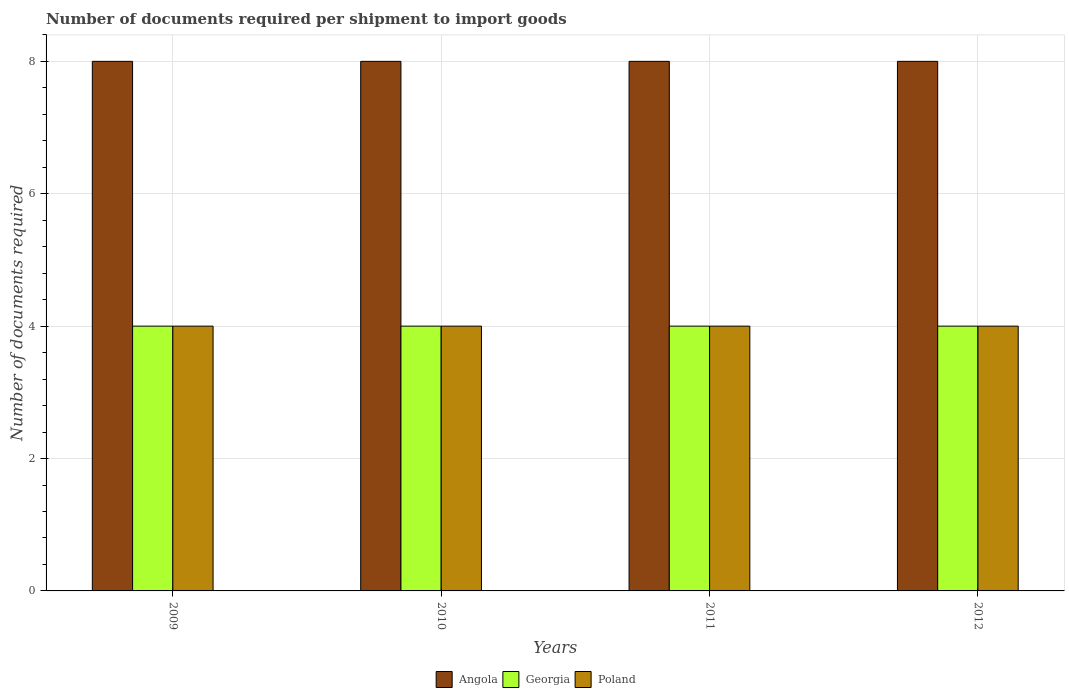Are the number of bars on each tick of the X-axis equal?
Offer a terse response. Yes. What is the label of the 1st group of bars from the left?
Provide a succinct answer. 2009. In how many cases, is the number of bars for a given year not equal to the number of legend labels?
Provide a short and direct response. 0. What is the number of documents required per shipment to import goods in Poland in 2012?
Offer a very short reply. 4. Across all years, what is the maximum number of documents required per shipment to import goods in Angola?
Provide a short and direct response. 8. Across all years, what is the minimum number of documents required per shipment to import goods in Angola?
Offer a very short reply. 8. In which year was the number of documents required per shipment to import goods in Georgia maximum?
Provide a short and direct response. 2009. In which year was the number of documents required per shipment to import goods in Poland minimum?
Provide a succinct answer. 2009. What is the total number of documents required per shipment to import goods in Georgia in the graph?
Ensure brevity in your answer.  16. What is the difference between the number of documents required per shipment to import goods in Angola in 2011 and the number of documents required per shipment to import goods in Poland in 2009?
Offer a very short reply. 4. In the year 2009, what is the difference between the number of documents required per shipment to import goods in Poland and number of documents required per shipment to import goods in Angola?
Your answer should be very brief. -4. In how many years, is the number of documents required per shipment to import goods in Angola greater than 2.4?
Your answer should be compact. 4. Is the number of documents required per shipment to import goods in Georgia in 2010 less than that in 2011?
Give a very brief answer. No. What is the difference between the highest and the second highest number of documents required per shipment to import goods in Poland?
Your answer should be very brief. 0. Is the sum of the number of documents required per shipment to import goods in Angola in 2010 and 2012 greater than the maximum number of documents required per shipment to import goods in Georgia across all years?
Provide a short and direct response. Yes. What does the 1st bar from the left in 2009 represents?
Make the answer very short. Angola. What does the 3rd bar from the right in 2011 represents?
Provide a short and direct response. Angola. Is it the case that in every year, the sum of the number of documents required per shipment to import goods in Georgia and number of documents required per shipment to import goods in Angola is greater than the number of documents required per shipment to import goods in Poland?
Provide a succinct answer. Yes. How many bars are there?
Ensure brevity in your answer.  12. Are all the bars in the graph horizontal?
Your answer should be compact. No. Does the graph contain grids?
Your answer should be compact. Yes. How many legend labels are there?
Keep it short and to the point. 3. How are the legend labels stacked?
Offer a terse response. Horizontal. What is the title of the graph?
Ensure brevity in your answer.  Number of documents required per shipment to import goods. What is the label or title of the Y-axis?
Provide a short and direct response. Number of documents required. What is the Number of documents required in Georgia in 2009?
Your response must be concise. 4. What is the Number of documents required of Poland in 2009?
Your response must be concise. 4. What is the Number of documents required of Angola in 2010?
Offer a very short reply. 8. What is the Number of documents required in Georgia in 2010?
Provide a succinct answer. 4. What is the Number of documents required of Poland in 2011?
Your answer should be very brief. 4. What is the Number of documents required in Angola in 2012?
Your response must be concise. 8. What is the Number of documents required in Poland in 2012?
Give a very brief answer. 4. Across all years, what is the maximum Number of documents required of Angola?
Provide a short and direct response. 8. Across all years, what is the maximum Number of documents required in Georgia?
Provide a succinct answer. 4. Across all years, what is the maximum Number of documents required of Poland?
Your answer should be compact. 4. What is the total Number of documents required in Angola in the graph?
Ensure brevity in your answer.  32. What is the total Number of documents required of Poland in the graph?
Your answer should be very brief. 16. What is the difference between the Number of documents required of Angola in 2009 and that in 2010?
Offer a terse response. 0. What is the difference between the Number of documents required of Poland in 2009 and that in 2010?
Provide a short and direct response. 0. What is the difference between the Number of documents required of Georgia in 2009 and that in 2011?
Give a very brief answer. 0. What is the difference between the Number of documents required of Poland in 2009 and that in 2011?
Provide a short and direct response. 0. What is the difference between the Number of documents required of Angola in 2009 and that in 2012?
Make the answer very short. 0. What is the difference between the Number of documents required in Georgia in 2009 and that in 2012?
Offer a very short reply. 0. What is the difference between the Number of documents required in Georgia in 2010 and that in 2011?
Make the answer very short. 0. What is the difference between the Number of documents required of Poland in 2010 and that in 2011?
Offer a very short reply. 0. What is the difference between the Number of documents required of Angola in 2010 and that in 2012?
Your response must be concise. 0. What is the difference between the Number of documents required of Poland in 2010 and that in 2012?
Keep it short and to the point. 0. What is the difference between the Number of documents required in Angola in 2011 and that in 2012?
Give a very brief answer. 0. What is the difference between the Number of documents required in Georgia in 2011 and that in 2012?
Your response must be concise. 0. What is the difference between the Number of documents required of Poland in 2011 and that in 2012?
Provide a succinct answer. 0. What is the difference between the Number of documents required in Georgia in 2009 and the Number of documents required in Poland in 2010?
Keep it short and to the point. 0. What is the difference between the Number of documents required of Angola in 2009 and the Number of documents required of Poland in 2011?
Make the answer very short. 4. What is the difference between the Number of documents required in Georgia in 2009 and the Number of documents required in Poland in 2011?
Offer a terse response. 0. What is the difference between the Number of documents required of Angola in 2009 and the Number of documents required of Georgia in 2012?
Your answer should be compact. 4. What is the difference between the Number of documents required in Georgia in 2010 and the Number of documents required in Poland in 2011?
Your response must be concise. 0. What is the difference between the Number of documents required of Angola in 2011 and the Number of documents required of Georgia in 2012?
Your answer should be very brief. 4. What is the average Number of documents required in Georgia per year?
Offer a very short reply. 4. In the year 2009, what is the difference between the Number of documents required in Angola and Number of documents required in Poland?
Offer a terse response. 4. In the year 2010, what is the difference between the Number of documents required in Angola and Number of documents required in Georgia?
Provide a succinct answer. 4. In the year 2010, what is the difference between the Number of documents required of Angola and Number of documents required of Poland?
Give a very brief answer. 4. In the year 2010, what is the difference between the Number of documents required of Georgia and Number of documents required of Poland?
Your answer should be very brief. 0. In the year 2011, what is the difference between the Number of documents required in Georgia and Number of documents required in Poland?
Keep it short and to the point. 0. What is the ratio of the Number of documents required of Angola in 2009 to that in 2010?
Ensure brevity in your answer.  1. What is the ratio of the Number of documents required in Georgia in 2009 to that in 2011?
Your answer should be compact. 1. What is the ratio of the Number of documents required of Poland in 2009 to that in 2012?
Your response must be concise. 1. What is the ratio of the Number of documents required of Georgia in 2010 to that in 2012?
Your answer should be very brief. 1. What is the ratio of the Number of documents required in Poland in 2010 to that in 2012?
Make the answer very short. 1. What is the difference between the highest and the second highest Number of documents required in Georgia?
Offer a terse response. 0. What is the difference between the highest and the second highest Number of documents required of Poland?
Keep it short and to the point. 0. What is the difference between the highest and the lowest Number of documents required in Angola?
Provide a short and direct response. 0. What is the difference between the highest and the lowest Number of documents required of Georgia?
Give a very brief answer. 0. What is the difference between the highest and the lowest Number of documents required of Poland?
Provide a short and direct response. 0. 